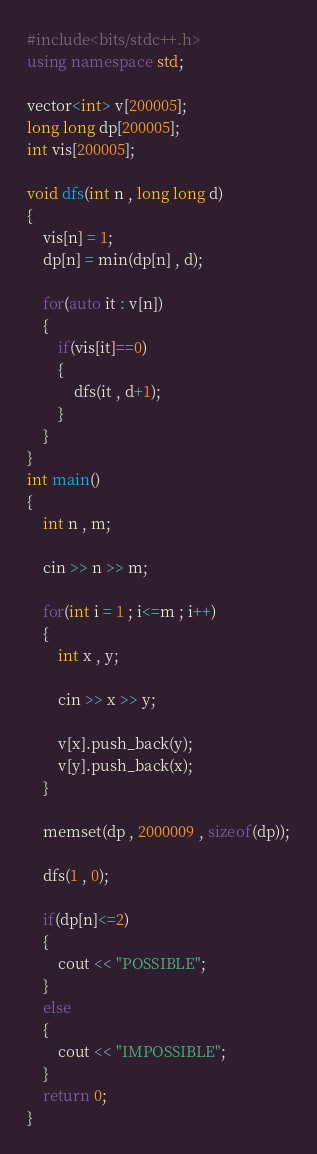Convert code to text. <code><loc_0><loc_0><loc_500><loc_500><_C++_>#include<bits/stdc++.h>
using namespace std;

vector<int> v[200005];
long long dp[200005];
int vis[200005];

void dfs(int n , long long d)
{
    vis[n] = 1;
    dp[n] = min(dp[n] , d);

    for(auto it : v[n])
    {
        if(vis[it]==0)
        {
            dfs(it , d+1);
        }
    }
}
int main()
{
    int n , m;

    cin >> n >> m;

    for(int i = 1 ; i<=m ; i++)
    {
        int x , y;

        cin >> x >> y;

        v[x].push_back(y);
        v[y].push_back(x);
    }

    memset(dp , 2000009 , sizeof(dp));

    dfs(1 , 0);

    if(dp[n]<=2)
    {
        cout << "POSSIBLE";
    }
    else
    {
        cout << "IMPOSSIBLE";
    }
    return 0;
}
</code> 